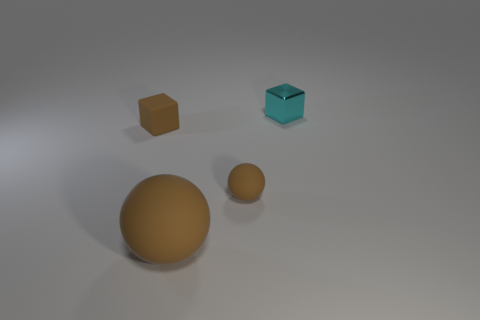Add 2 big red blocks. How many objects exist? 6 Subtract all tiny cyan metal things. Subtract all small green rubber cylinders. How many objects are left? 3 Add 1 large rubber things. How many large rubber things are left? 2 Add 2 cyan things. How many cyan things exist? 3 Subtract 0 blue blocks. How many objects are left? 4 